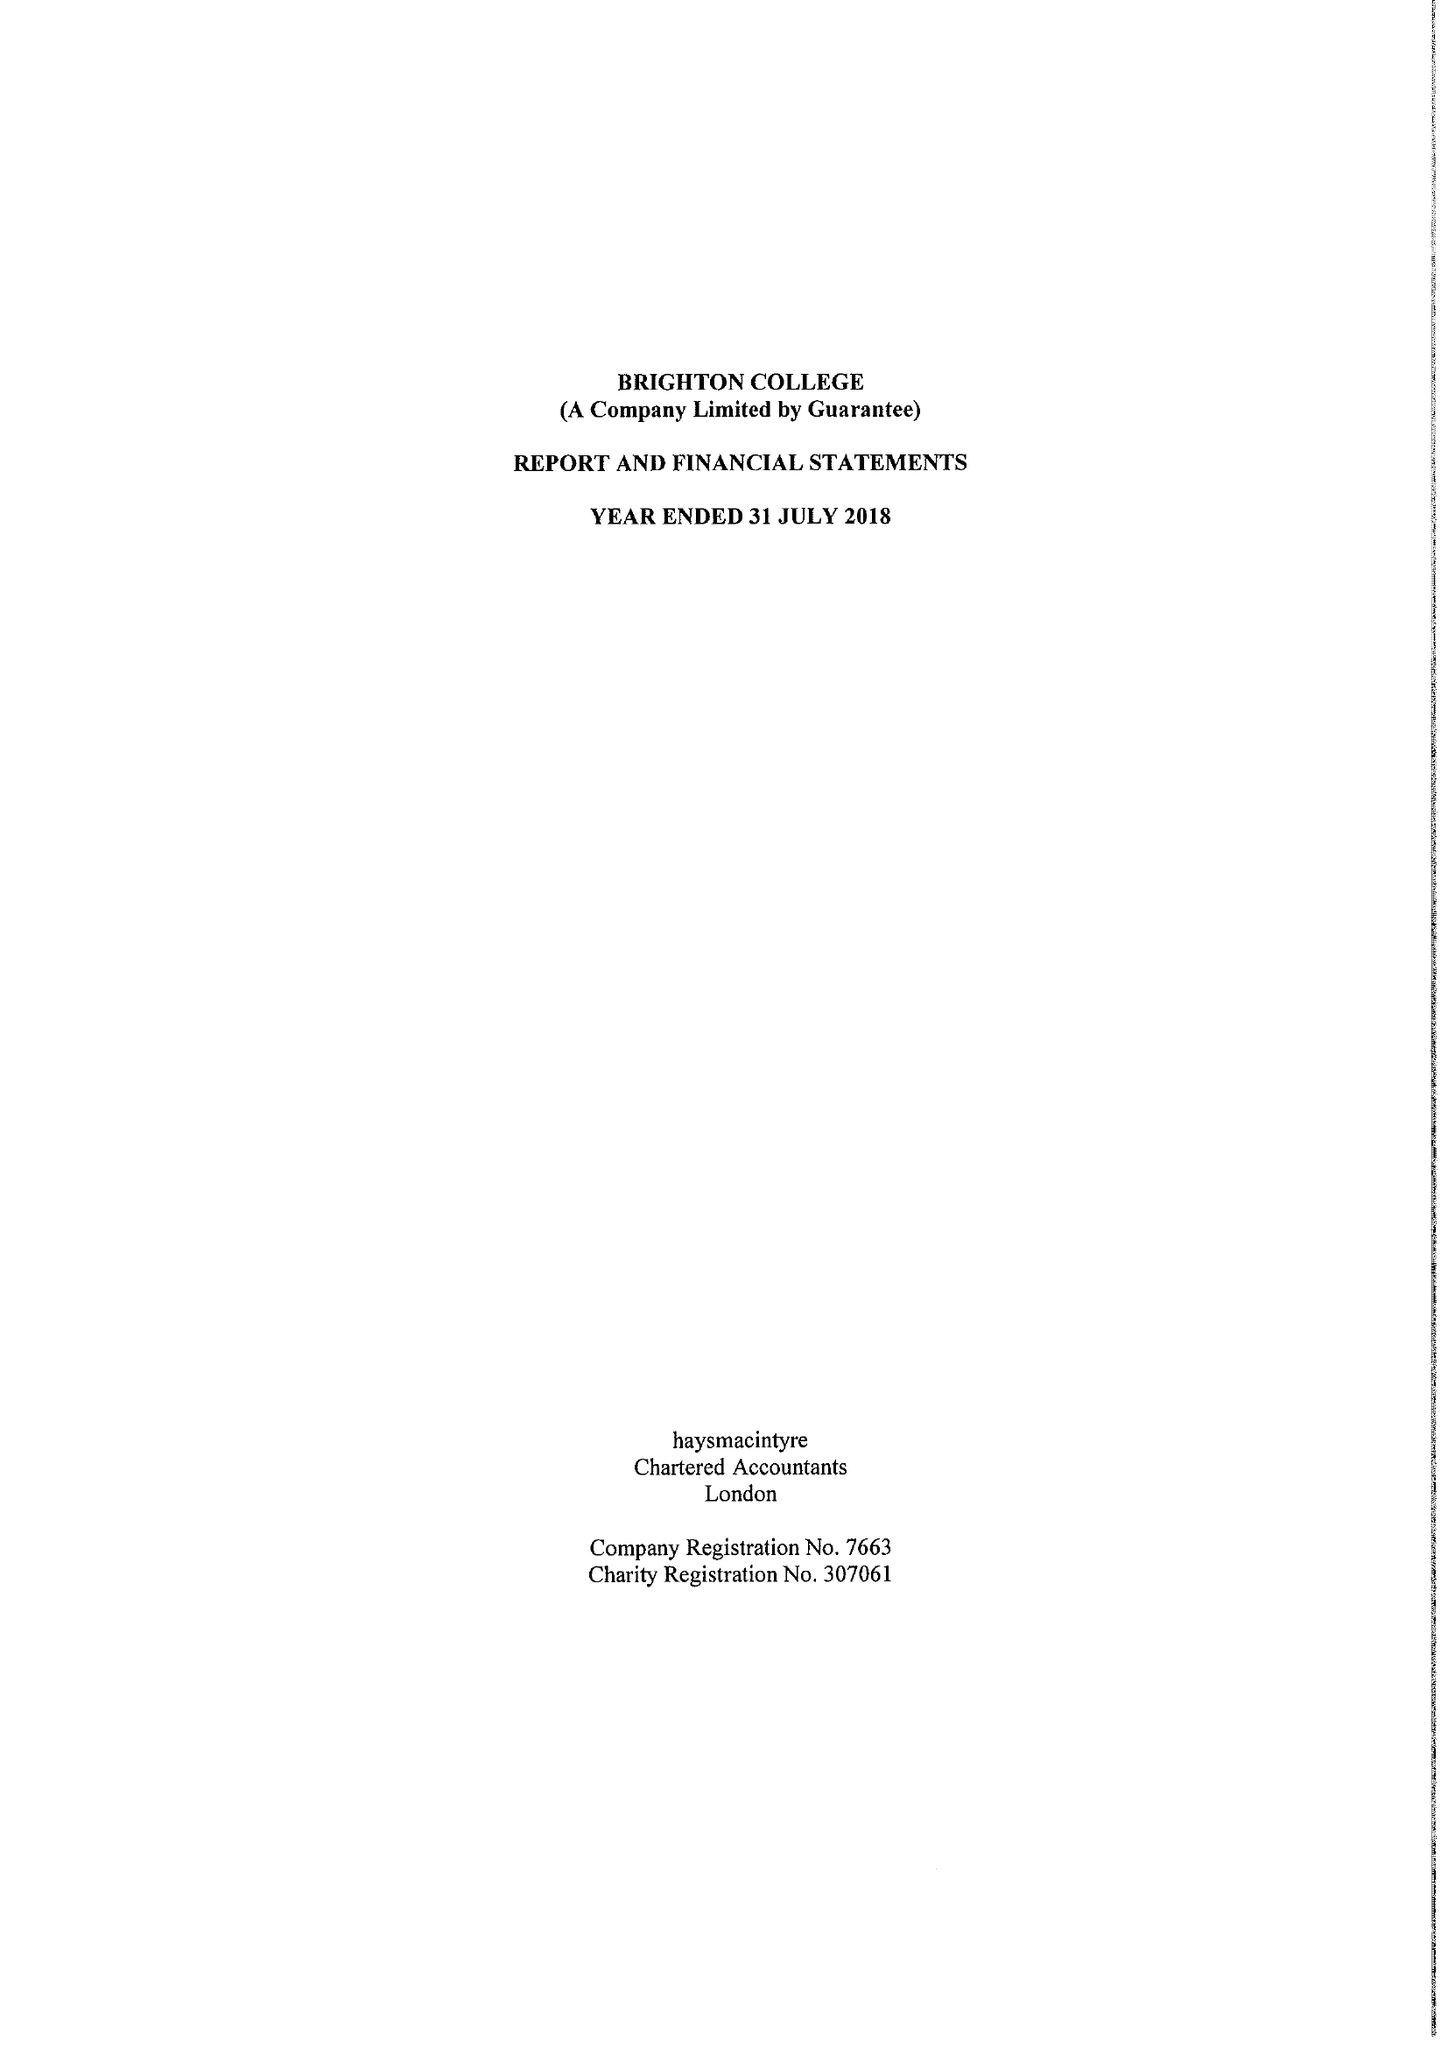What is the value for the address__street_line?
Answer the question using a single word or phrase. EASTERN ROAD 